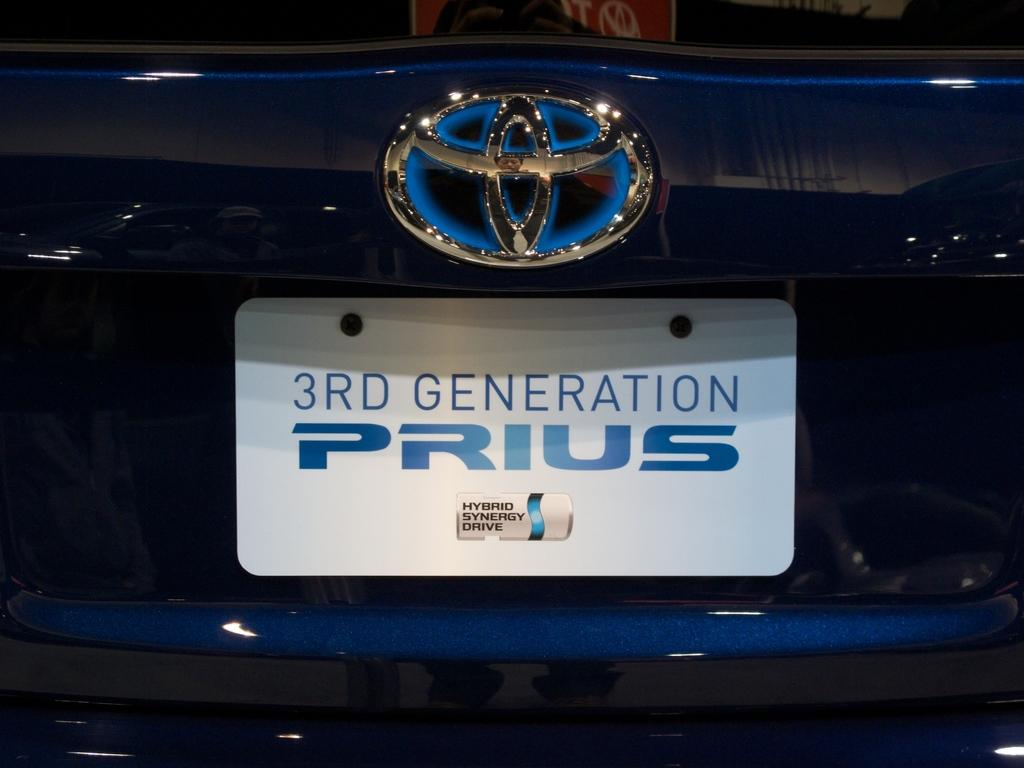<image>
Share a concise interpretation of the image provided. A Toyota with the license plate 3rd Generation Prius. 